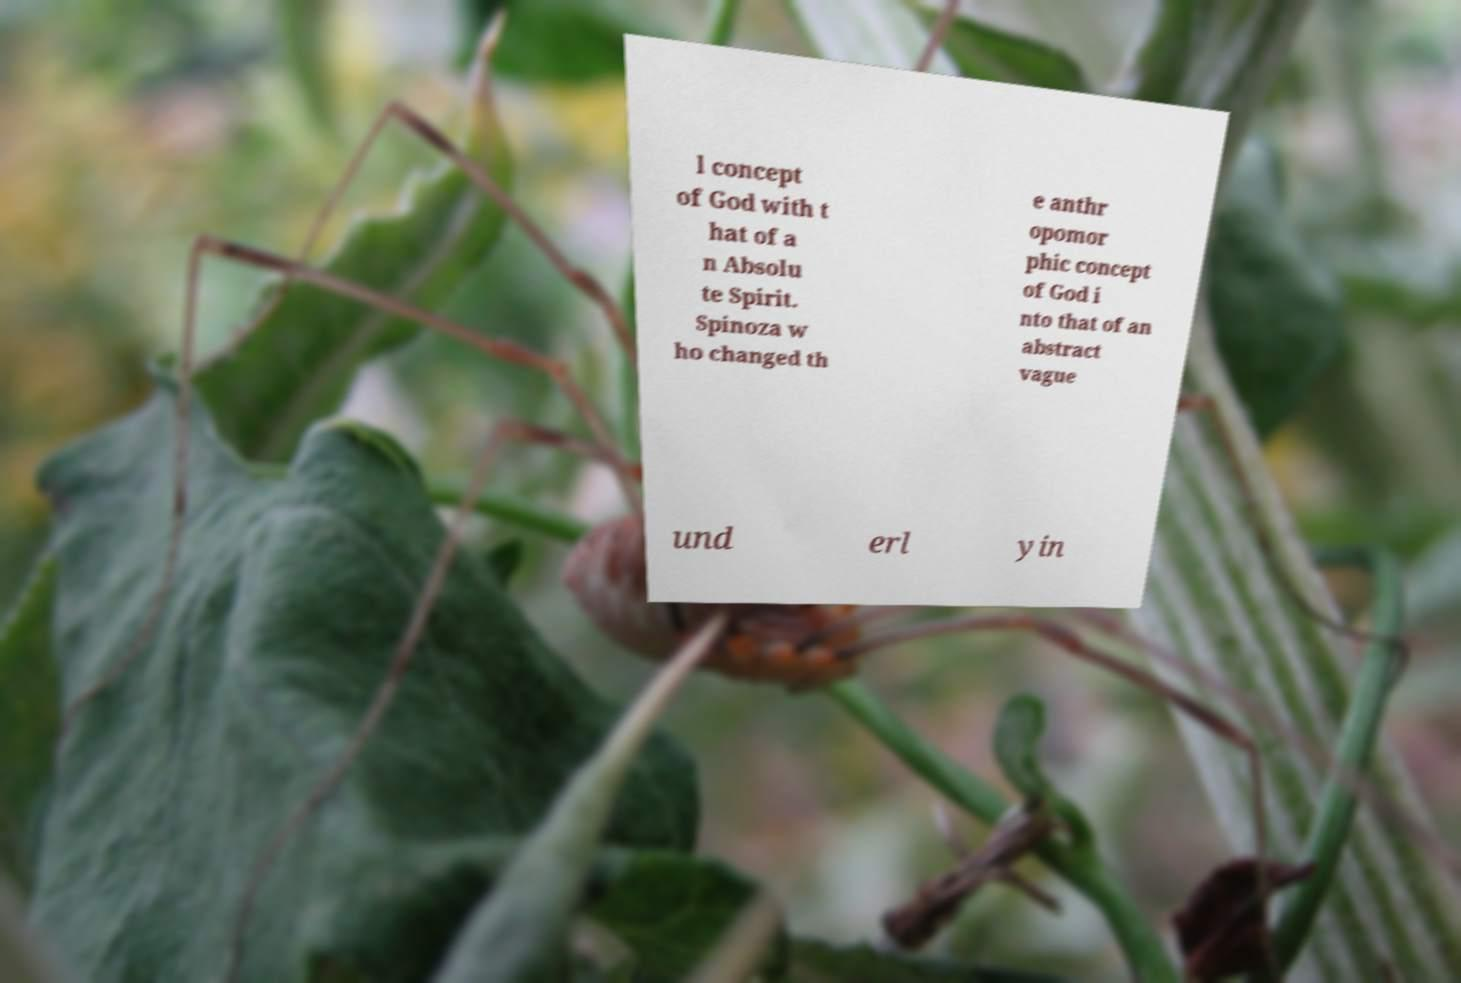What messages or text are displayed in this image? I need them in a readable, typed format. l concept of God with t hat of a n Absolu te Spirit. Spinoza w ho changed th e anthr opomor phic concept of God i nto that of an abstract vague und erl yin 